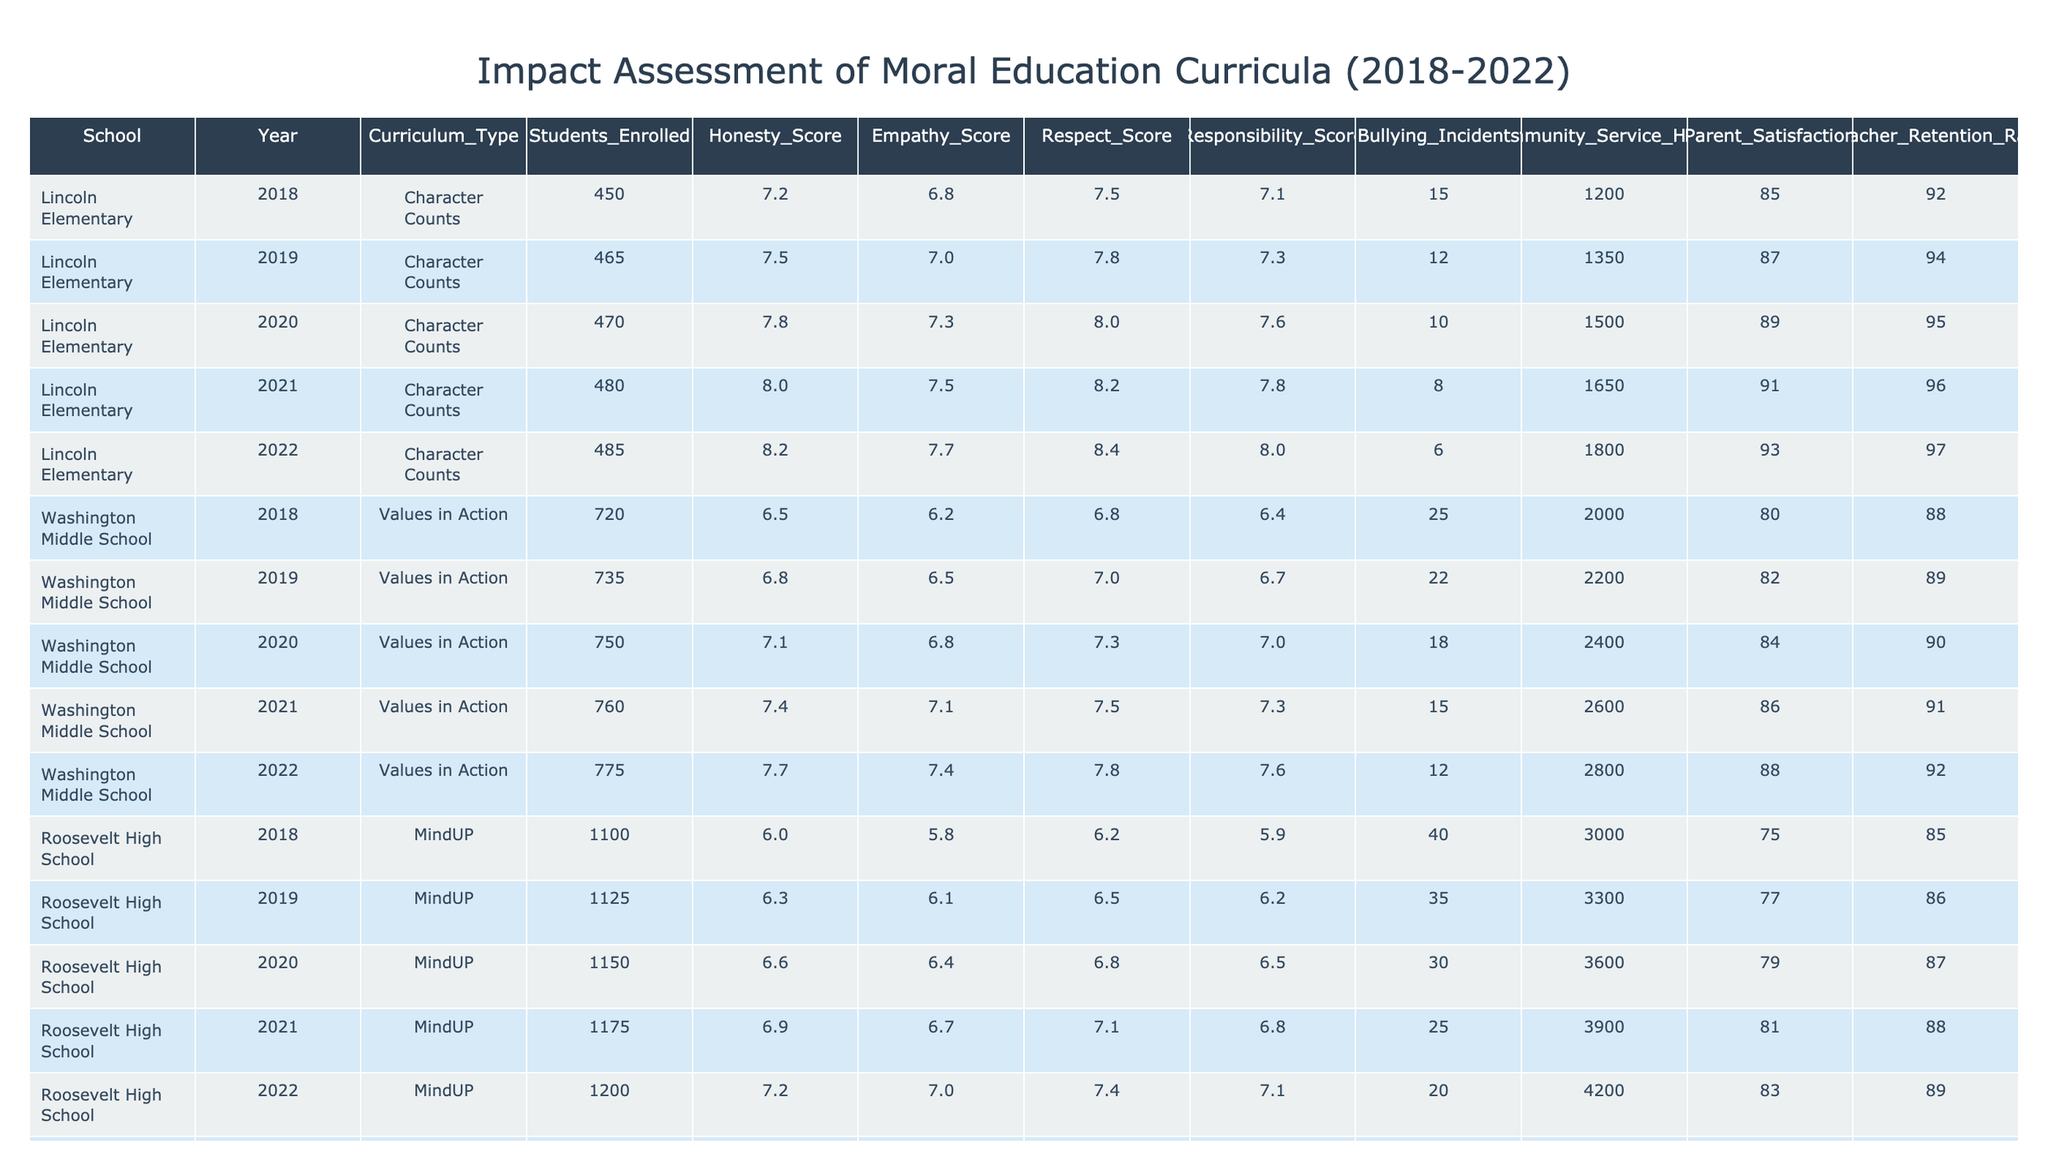What was the average honesty score for Lincoln Elementary from 2018 to 2022? To calculate the average honesty score, sum the scores for Lincoln Elementary over the five years: (7.2 + 7.5 + 7.8 + 8.0 + 8.2) = 38.7. Then divide by the number of years (5): 38.7 / 5 = 7.74.
Answer: 7.74 How many bullying incidents were reported at Roosevelt High School in 2020? The table lists the number of bullying incidents for each year at Roosevelt High School. In 2020, the number of bullying incidents was reported as 30.
Answer: 30 Did the teacher retention rate at Washington Middle School improve from 2018 to 2022? The teacher retention rates for Washington Middle School from 2018 to 2022 are 88%, 89%, 90%, 91%, and 92% respectively. Since the rates increased over the years, it shows an improvement.
Answer: Yes Which curriculum had the highest average empathy score over the five years? First, calculate the average empathy scores for each curriculum. For Lincoln Elementary: (6.8 + 7.0 + 7.3 + 7.5 + 7.7) / 5 = 7.26; Washington Middle School: (6.2 + 6.5 + 6.8 + 7.1 + 7.4) / 5 = 6.82; Roosevelt High School: (5.8 + 6.1 + 6.4 + 6.7 + 7.0) / 5 = 6.24; Jefferson Academy: (6.6 + 6.9 + 7.2 + 7.5 + 7.8) / 5 = 7.2. The highest average is from Lincoln Elementary with 7.26.
Answer: Character Counts What was the total community service hours reported for all schools in 2021? To find the total community service hours for 2021, sum the values for each school: Lincoln Elementary (1650) + Washington Middle School (2600) + Roosevelt High School (3900) + Jefferson Academy (1950) = 1650 + 2600 + 3900 + 1950 = 10100.
Answer: 10100 In which year did Roosevelt High School have the lowest honesty score? Looking across the years for Roosevelt High School, the honesty scores reported are: 6.0 (2018), 6.3 (2019), 6.6 (2020), 6.9 (2021), and 7.2 (2022). The lowest score is 6.0 in 2018.
Answer: 2018 What is the percentage increase in parent satisfaction at Jefferson Academy from 2018 to 2022? The parent satisfaction rates for Jefferson Academy in 2018 (82%) and 2022 (90%) need to be compared. The increase is 90% - 82% = 8%. The percentage increase is (8% / 82%) * 100 = approximately 9.76%, rounding this to whole numbers is 10%.
Answer: 10% Was there a decrease in bullying incidents at Lincoln Elementary from 2018 to 2022? The bullying incidents at Lincoln Elementary were 15 (2018), 12 (2019), 10 (2020), 8 (2021), and 6 (2022). Since the numbers went from 15 to 6, this shows a decrease each year.
Answer: Yes 